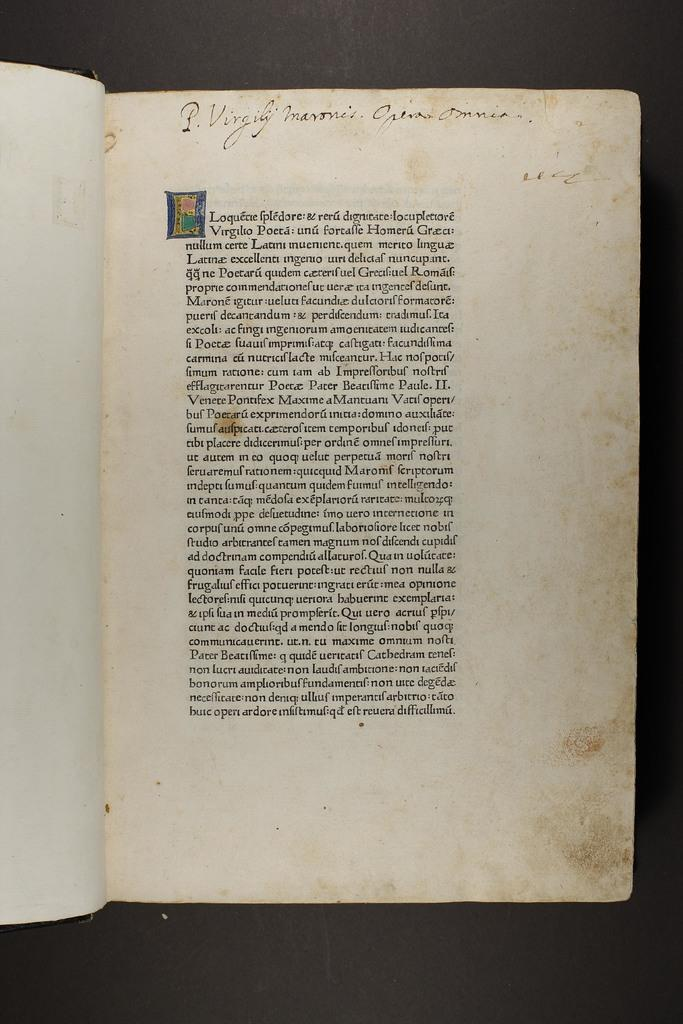What object can be seen in the image? There is a book in the image. What is inside the book? The book contains text. Is there a veil covering the book in the image? No, there is no veil present in the image. 